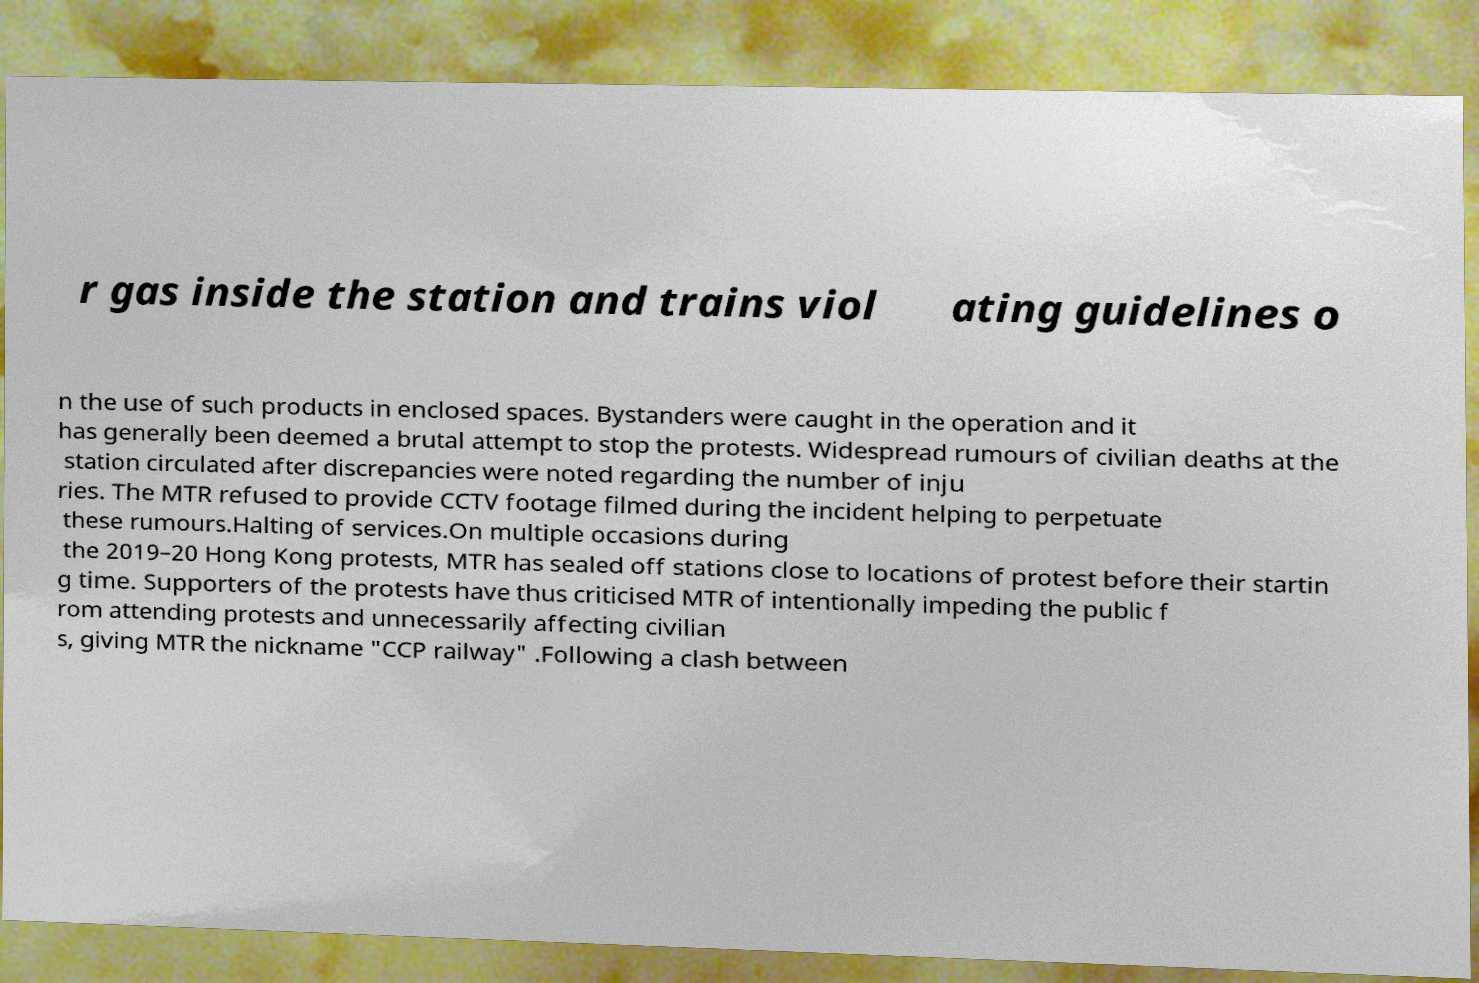For documentation purposes, I need the text within this image transcribed. Could you provide that? r gas inside the station and trains viol ating guidelines o n the use of such products in enclosed spaces. Bystanders were caught in the operation and it has generally been deemed a brutal attempt to stop the protests. Widespread rumours of civilian deaths at the station circulated after discrepancies were noted regarding the number of inju ries. The MTR refused to provide CCTV footage filmed during the incident helping to perpetuate these rumours.Halting of services.On multiple occasions during the 2019–20 Hong Kong protests, MTR has sealed off stations close to locations of protest before their startin g time. Supporters of the protests have thus criticised MTR of intentionally impeding the public f rom attending protests and unnecessarily affecting civilian s, giving MTR the nickname "CCP railway" .Following a clash between 